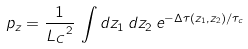Convert formula to latex. <formula><loc_0><loc_0><loc_500><loc_500>p _ { z } = \frac { 1 } { { L _ { C } } ^ { 2 } } \, \int d z _ { 1 } \, d z _ { 2 } \, e ^ { - \Delta \tau ( z _ { 1 } , z _ { 2 } ) / \tau _ { c } }</formula> 